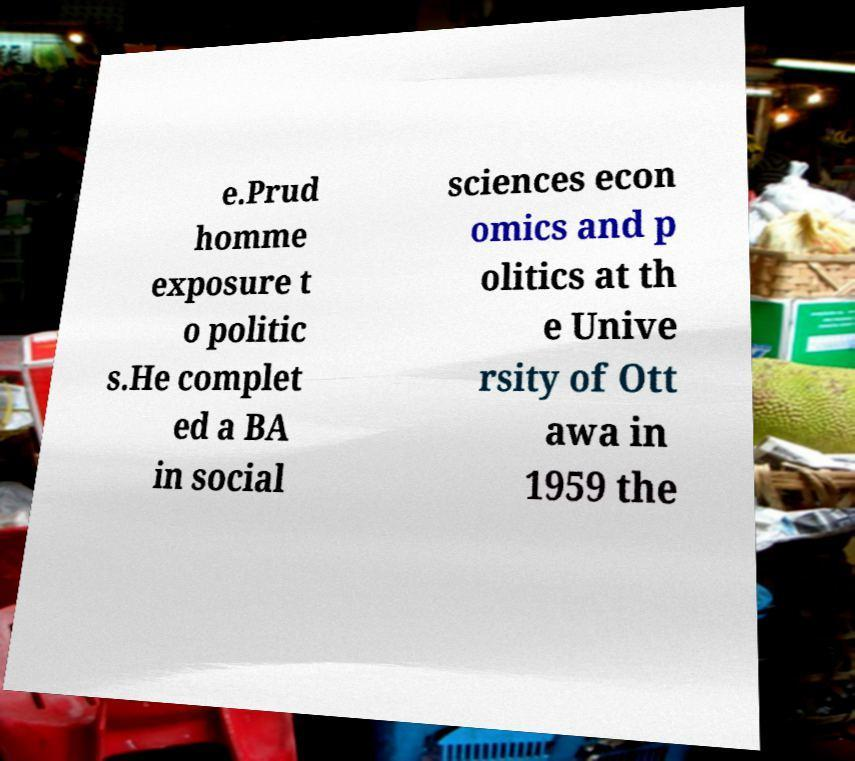Could you assist in decoding the text presented in this image and type it out clearly? e.Prud homme exposure t o politic s.He complet ed a BA in social sciences econ omics and p olitics at th e Unive rsity of Ott awa in 1959 the 